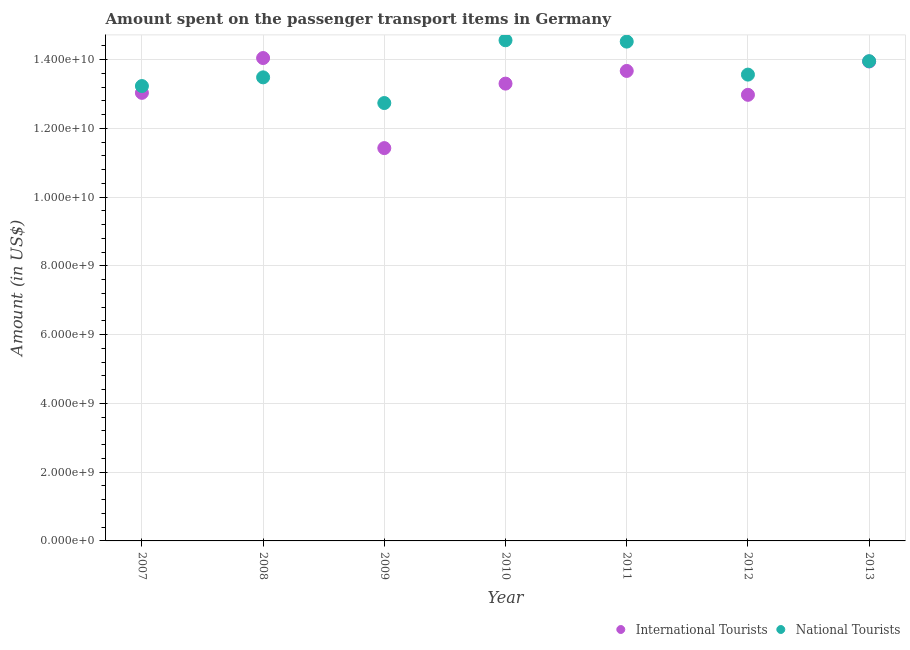How many different coloured dotlines are there?
Provide a short and direct response. 2. What is the amount spent on transport items of international tourists in 2012?
Ensure brevity in your answer.  1.30e+1. Across all years, what is the maximum amount spent on transport items of international tourists?
Offer a very short reply. 1.40e+1. Across all years, what is the minimum amount spent on transport items of national tourists?
Offer a terse response. 1.27e+1. In which year was the amount spent on transport items of national tourists maximum?
Offer a terse response. 2010. What is the total amount spent on transport items of international tourists in the graph?
Provide a short and direct response. 9.24e+1. What is the difference between the amount spent on transport items of international tourists in 2007 and that in 2009?
Ensure brevity in your answer.  1.61e+09. What is the difference between the amount spent on transport items of international tourists in 2010 and the amount spent on transport items of national tourists in 2009?
Give a very brief answer. 5.65e+08. What is the average amount spent on transport items of international tourists per year?
Give a very brief answer. 1.32e+1. In the year 2008, what is the difference between the amount spent on transport items of international tourists and amount spent on transport items of national tourists?
Provide a succinct answer. 5.62e+08. What is the ratio of the amount spent on transport items of national tourists in 2009 to that in 2010?
Your answer should be very brief. 0.87. What is the difference between the highest and the lowest amount spent on transport items of international tourists?
Offer a very short reply. 2.62e+09. Does the amount spent on transport items of international tourists monotonically increase over the years?
Your answer should be very brief. No. Is the amount spent on transport items of international tourists strictly greater than the amount spent on transport items of national tourists over the years?
Provide a succinct answer. No. Is the amount spent on transport items of national tourists strictly less than the amount spent on transport items of international tourists over the years?
Your answer should be compact. No. How many years are there in the graph?
Offer a terse response. 7. What is the title of the graph?
Offer a very short reply. Amount spent on the passenger transport items in Germany. What is the label or title of the X-axis?
Provide a short and direct response. Year. What is the label or title of the Y-axis?
Make the answer very short. Amount (in US$). What is the Amount (in US$) of International Tourists in 2007?
Offer a terse response. 1.30e+1. What is the Amount (in US$) of National Tourists in 2007?
Your answer should be compact. 1.32e+1. What is the Amount (in US$) of International Tourists in 2008?
Offer a very short reply. 1.40e+1. What is the Amount (in US$) of National Tourists in 2008?
Keep it short and to the point. 1.35e+1. What is the Amount (in US$) in International Tourists in 2009?
Provide a short and direct response. 1.14e+1. What is the Amount (in US$) of National Tourists in 2009?
Keep it short and to the point. 1.27e+1. What is the Amount (in US$) in International Tourists in 2010?
Offer a very short reply. 1.33e+1. What is the Amount (in US$) in National Tourists in 2010?
Your response must be concise. 1.46e+1. What is the Amount (in US$) of International Tourists in 2011?
Make the answer very short. 1.37e+1. What is the Amount (in US$) of National Tourists in 2011?
Offer a very short reply. 1.45e+1. What is the Amount (in US$) in International Tourists in 2012?
Give a very brief answer. 1.30e+1. What is the Amount (in US$) of National Tourists in 2012?
Give a very brief answer. 1.36e+1. What is the Amount (in US$) of International Tourists in 2013?
Make the answer very short. 1.39e+1. What is the Amount (in US$) in National Tourists in 2013?
Make the answer very short. 1.40e+1. Across all years, what is the maximum Amount (in US$) of International Tourists?
Your answer should be compact. 1.40e+1. Across all years, what is the maximum Amount (in US$) in National Tourists?
Give a very brief answer. 1.46e+1. Across all years, what is the minimum Amount (in US$) of International Tourists?
Ensure brevity in your answer.  1.14e+1. Across all years, what is the minimum Amount (in US$) in National Tourists?
Offer a terse response. 1.27e+1. What is the total Amount (in US$) in International Tourists in the graph?
Make the answer very short. 9.24e+1. What is the total Amount (in US$) of National Tourists in the graph?
Make the answer very short. 9.61e+1. What is the difference between the Amount (in US$) of International Tourists in 2007 and that in 2008?
Make the answer very short. -1.01e+09. What is the difference between the Amount (in US$) of National Tourists in 2007 and that in 2008?
Keep it short and to the point. -2.53e+08. What is the difference between the Amount (in US$) of International Tourists in 2007 and that in 2009?
Provide a short and direct response. 1.61e+09. What is the difference between the Amount (in US$) of National Tourists in 2007 and that in 2009?
Offer a very short reply. 4.94e+08. What is the difference between the Amount (in US$) of International Tourists in 2007 and that in 2010?
Give a very brief answer. -2.69e+08. What is the difference between the Amount (in US$) in National Tourists in 2007 and that in 2010?
Provide a succinct answer. -1.33e+09. What is the difference between the Amount (in US$) in International Tourists in 2007 and that in 2011?
Keep it short and to the point. -6.38e+08. What is the difference between the Amount (in US$) of National Tourists in 2007 and that in 2011?
Your response must be concise. -1.29e+09. What is the difference between the Amount (in US$) of International Tourists in 2007 and that in 2012?
Your answer should be very brief. 5.70e+07. What is the difference between the Amount (in US$) in National Tourists in 2007 and that in 2012?
Your response must be concise. -3.33e+08. What is the difference between the Amount (in US$) of International Tourists in 2007 and that in 2013?
Make the answer very short. -9.13e+08. What is the difference between the Amount (in US$) in National Tourists in 2007 and that in 2013?
Your answer should be very brief. -7.23e+08. What is the difference between the Amount (in US$) of International Tourists in 2008 and that in 2009?
Keep it short and to the point. 2.62e+09. What is the difference between the Amount (in US$) of National Tourists in 2008 and that in 2009?
Ensure brevity in your answer.  7.47e+08. What is the difference between the Amount (in US$) in International Tourists in 2008 and that in 2010?
Offer a very short reply. 7.44e+08. What is the difference between the Amount (in US$) in National Tourists in 2008 and that in 2010?
Ensure brevity in your answer.  -1.08e+09. What is the difference between the Amount (in US$) in International Tourists in 2008 and that in 2011?
Provide a short and direct response. 3.75e+08. What is the difference between the Amount (in US$) in National Tourists in 2008 and that in 2011?
Provide a short and direct response. -1.04e+09. What is the difference between the Amount (in US$) of International Tourists in 2008 and that in 2012?
Ensure brevity in your answer.  1.07e+09. What is the difference between the Amount (in US$) in National Tourists in 2008 and that in 2012?
Your answer should be compact. -8.00e+07. What is the difference between the Amount (in US$) of International Tourists in 2008 and that in 2013?
Offer a very short reply. 1.00e+08. What is the difference between the Amount (in US$) of National Tourists in 2008 and that in 2013?
Keep it short and to the point. -4.70e+08. What is the difference between the Amount (in US$) in International Tourists in 2009 and that in 2010?
Give a very brief answer. -1.88e+09. What is the difference between the Amount (in US$) in National Tourists in 2009 and that in 2010?
Your answer should be very brief. -1.83e+09. What is the difference between the Amount (in US$) in International Tourists in 2009 and that in 2011?
Your answer should be very brief. -2.24e+09. What is the difference between the Amount (in US$) of National Tourists in 2009 and that in 2011?
Offer a very short reply. -1.79e+09. What is the difference between the Amount (in US$) of International Tourists in 2009 and that in 2012?
Keep it short and to the point. -1.55e+09. What is the difference between the Amount (in US$) in National Tourists in 2009 and that in 2012?
Make the answer very short. -8.27e+08. What is the difference between the Amount (in US$) of International Tourists in 2009 and that in 2013?
Offer a very short reply. -2.52e+09. What is the difference between the Amount (in US$) in National Tourists in 2009 and that in 2013?
Make the answer very short. -1.22e+09. What is the difference between the Amount (in US$) in International Tourists in 2010 and that in 2011?
Keep it short and to the point. -3.69e+08. What is the difference between the Amount (in US$) in National Tourists in 2010 and that in 2011?
Offer a very short reply. 3.90e+07. What is the difference between the Amount (in US$) in International Tourists in 2010 and that in 2012?
Your answer should be compact. 3.26e+08. What is the difference between the Amount (in US$) in National Tourists in 2010 and that in 2012?
Keep it short and to the point. 9.99e+08. What is the difference between the Amount (in US$) of International Tourists in 2010 and that in 2013?
Provide a short and direct response. -6.44e+08. What is the difference between the Amount (in US$) of National Tourists in 2010 and that in 2013?
Provide a short and direct response. 6.09e+08. What is the difference between the Amount (in US$) in International Tourists in 2011 and that in 2012?
Offer a very short reply. 6.95e+08. What is the difference between the Amount (in US$) of National Tourists in 2011 and that in 2012?
Your response must be concise. 9.60e+08. What is the difference between the Amount (in US$) of International Tourists in 2011 and that in 2013?
Make the answer very short. -2.75e+08. What is the difference between the Amount (in US$) in National Tourists in 2011 and that in 2013?
Offer a very short reply. 5.70e+08. What is the difference between the Amount (in US$) of International Tourists in 2012 and that in 2013?
Give a very brief answer. -9.70e+08. What is the difference between the Amount (in US$) in National Tourists in 2012 and that in 2013?
Offer a terse response. -3.90e+08. What is the difference between the Amount (in US$) of International Tourists in 2007 and the Amount (in US$) of National Tourists in 2008?
Give a very brief answer. -4.51e+08. What is the difference between the Amount (in US$) of International Tourists in 2007 and the Amount (in US$) of National Tourists in 2009?
Give a very brief answer. 2.96e+08. What is the difference between the Amount (in US$) in International Tourists in 2007 and the Amount (in US$) in National Tourists in 2010?
Offer a very short reply. -1.53e+09. What is the difference between the Amount (in US$) of International Tourists in 2007 and the Amount (in US$) of National Tourists in 2011?
Provide a short and direct response. -1.49e+09. What is the difference between the Amount (in US$) in International Tourists in 2007 and the Amount (in US$) in National Tourists in 2012?
Keep it short and to the point. -5.31e+08. What is the difference between the Amount (in US$) in International Tourists in 2007 and the Amount (in US$) in National Tourists in 2013?
Your response must be concise. -9.21e+08. What is the difference between the Amount (in US$) in International Tourists in 2008 and the Amount (in US$) in National Tourists in 2009?
Make the answer very short. 1.31e+09. What is the difference between the Amount (in US$) in International Tourists in 2008 and the Amount (in US$) in National Tourists in 2010?
Ensure brevity in your answer.  -5.17e+08. What is the difference between the Amount (in US$) in International Tourists in 2008 and the Amount (in US$) in National Tourists in 2011?
Provide a short and direct response. -4.78e+08. What is the difference between the Amount (in US$) in International Tourists in 2008 and the Amount (in US$) in National Tourists in 2012?
Your answer should be very brief. 4.82e+08. What is the difference between the Amount (in US$) of International Tourists in 2008 and the Amount (in US$) of National Tourists in 2013?
Keep it short and to the point. 9.20e+07. What is the difference between the Amount (in US$) of International Tourists in 2009 and the Amount (in US$) of National Tourists in 2010?
Your response must be concise. -3.14e+09. What is the difference between the Amount (in US$) in International Tourists in 2009 and the Amount (in US$) in National Tourists in 2011?
Provide a short and direct response. -3.10e+09. What is the difference between the Amount (in US$) of International Tourists in 2009 and the Amount (in US$) of National Tourists in 2012?
Ensure brevity in your answer.  -2.14e+09. What is the difference between the Amount (in US$) in International Tourists in 2009 and the Amount (in US$) in National Tourists in 2013?
Keep it short and to the point. -2.53e+09. What is the difference between the Amount (in US$) of International Tourists in 2010 and the Amount (in US$) of National Tourists in 2011?
Offer a very short reply. -1.22e+09. What is the difference between the Amount (in US$) in International Tourists in 2010 and the Amount (in US$) in National Tourists in 2012?
Provide a succinct answer. -2.62e+08. What is the difference between the Amount (in US$) in International Tourists in 2010 and the Amount (in US$) in National Tourists in 2013?
Your response must be concise. -6.52e+08. What is the difference between the Amount (in US$) in International Tourists in 2011 and the Amount (in US$) in National Tourists in 2012?
Your answer should be very brief. 1.07e+08. What is the difference between the Amount (in US$) in International Tourists in 2011 and the Amount (in US$) in National Tourists in 2013?
Provide a succinct answer. -2.83e+08. What is the difference between the Amount (in US$) of International Tourists in 2012 and the Amount (in US$) of National Tourists in 2013?
Your response must be concise. -9.78e+08. What is the average Amount (in US$) of International Tourists per year?
Your answer should be very brief. 1.32e+1. What is the average Amount (in US$) in National Tourists per year?
Your answer should be very brief. 1.37e+1. In the year 2007, what is the difference between the Amount (in US$) in International Tourists and Amount (in US$) in National Tourists?
Your response must be concise. -1.98e+08. In the year 2008, what is the difference between the Amount (in US$) in International Tourists and Amount (in US$) in National Tourists?
Offer a very short reply. 5.62e+08. In the year 2009, what is the difference between the Amount (in US$) of International Tourists and Amount (in US$) of National Tourists?
Your answer should be compact. -1.31e+09. In the year 2010, what is the difference between the Amount (in US$) in International Tourists and Amount (in US$) in National Tourists?
Give a very brief answer. -1.26e+09. In the year 2011, what is the difference between the Amount (in US$) of International Tourists and Amount (in US$) of National Tourists?
Keep it short and to the point. -8.53e+08. In the year 2012, what is the difference between the Amount (in US$) in International Tourists and Amount (in US$) in National Tourists?
Offer a very short reply. -5.88e+08. In the year 2013, what is the difference between the Amount (in US$) in International Tourists and Amount (in US$) in National Tourists?
Make the answer very short. -8.00e+06. What is the ratio of the Amount (in US$) of International Tourists in 2007 to that in 2008?
Keep it short and to the point. 0.93. What is the ratio of the Amount (in US$) in National Tourists in 2007 to that in 2008?
Keep it short and to the point. 0.98. What is the ratio of the Amount (in US$) in International Tourists in 2007 to that in 2009?
Give a very brief answer. 1.14. What is the ratio of the Amount (in US$) in National Tourists in 2007 to that in 2009?
Your response must be concise. 1.04. What is the ratio of the Amount (in US$) in International Tourists in 2007 to that in 2010?
Your answer should be compact. 0.98. What is the ratio of the Amount (in US$) of National Tourists in 2007 to that in 2010?
Provide a succinct answer. 0.91. What is the ratio of the Amount (in US$) of International Tourists in 2007 to that in 2011?
Your answer should be compact. 0.95. What is the ratio of the Amount (in US$) in National Tourists in 2007 to that in 2011?
Offer a very short reply. 0.91. What is the ratio of the Amount (in US$) in National Tourists in 2007 to that in 2012?
Offer a terse response. 0.98. What is the ratio of the Amount (in US$) of International Tourists in 2007 to that in 2013?
Ensure brevity in your answer.  0.93. What is the ratio of the Amount (in US$) in National Tourists in 2007 to that in 2013?
Provide a succinct answer. 0.95. What is the ratio of the Amount (in US$) in International Tourists in 2008 to that in 2009?
Keep it short and to the point. 1.23. What is the ratio of the Amount (in US$) in National Tourists in 2008 to that in 2009?
Your response must be concise. 1.06. What is the ratio of the Amount (in US$) of International Tourists in 2008 to that in 2010?
Make the answer very short. 1.06. What is the ratio of the Amount (in US$) in National Tourists in 2008 to that in 2010?
Keep it short and to the point. 0.93. What is the ratio of the Amount (in US$) in International Tourists in 2008 to that in 2011?
Offer a terse response. 1.03. What is the ratio of the Amount (in US$) of National Tourists in 2008 to that in 2011?
Offer a terse response. 0.93. What is the ratio of the Amount (in US$) of International Tourists in 2008 to that in 2012?
Offer a very short reply. 1.08. What is the ratio of the Amount (in US$) of National Tourists in 2008 to that in 2012?
Make the answer very short. 0.99. What is the ratio of the Amount (in US$) of National Tourists in 2008 to that in 2013?
Your answer should be very brief. 0.97. What is the ratio of the Amount (in US$) in International Tourists in 2009 to that in 2010?
Ensure brevity in your answer.  0.86. What is the ratio of the Amount (in US$) of National Tourists in 2009 to that in 2010?
Keep it short and to the point. 0.87. What is the ratio of the Amount (in US$) of International Tourists in 2009 to that in 2011?
Offer a terse response. 0.84. What is the ratio of the Amount (in US$) in National Tourists in 2009 to that in 2011?
Give a very brief answer. 0.88. What is the ratio of the Amount (in US$) in International Tourists in 2009 to that in 2012?
Offer a terse response. 0.88. What is the ratio of the Amount (in US$) in National Tourists in 2009 to that in 2012?
Provide a short and direct response. 0.94. What is the ratio of the Amount (in US$) of International Tourists in 2009 to that in 2013?
Ensure brevity in your answer.  0.82. What is the ratio of the Amount (in US$) in National Tourists in 2009 to that in 2013?
Your answer should be compact. 0.91. What is the ratio of the Amount (in US$) in International Tourists in 2010 to that in 2011?
Make the answer very short. 0.97. What is the ratio of the Amount (in US$) in National Tourists in 2010 to that in 2011?
Your response must be concise. 1. What is the ratio of the Amount (in US$) in International Tourists in 2010 to that in 2012?
Keep it short and to the point. 1.03. What is the ratio of the Amount (in US$) in National Tourists in 2010 to that in 2012?
Offer a very short reply. 1.07. What is the ratio of the Amount (in US$) in International Tourists in 2010 to that in 2013?
Give a very brief answer. 0.95. What is the ratio of the Amount (in US$) of National Tourists in 2010 to that in 2013?
Provide a short and direct response. 1.04. What is the ratio of the Amount (in US$) in International Tourists in 2011 to that in 2012?
Provide a short and direct response. 1.05. What is the ratio of the Amount (in US$) in National Tourists in 2011 to that in 2012?
Offer a very short reply. 1.07. What is the ratio of the Amount (in US$) in International Tourists in 2011 to that in 2013?
Offer a terse response. 0.98. What is the ratio of the Amount (in US$) of National Tourists in 2011 to that in 2013?
Provide a short and direct response. 1.04. What is the ratio of the Amount (in US$) in International Tourists in 2012 to that in 2013?
Give a very brief answer. 0.93. What is the ratio of the Amount (in US$) of National Tourists in 2012 to that in 2013?
Give a very brief answer. 0.97. What is the difference between the highest and the second highest Amount (in US$) of National Tourists?
Your response must be concise. 3.90e+07. What is the difference between the highest and the lowest Amount (in US$) in International Tourists?
Ensure brevity in your answer.  2.62e+09. What is the difference between the highest and the lowest Amount (in US$) in National Tourists?
Ensure brevity in your answer.  1.83e+09. 